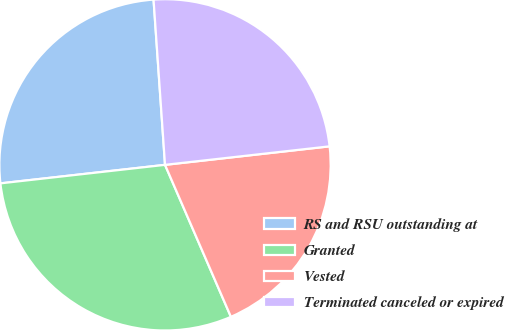Convert chart to OTSL. <chart><loc_0><loc_0><loc_500><loc_500><pie_chart><fcel>RS and RSU outstanding at<fcel>Granted<fcel>Vested<fcel>Terminated canceled or expired<nl><fcel>25.68%<fcel>29.73%<fcel>20.27%<fcel>24.32%<nl></chart> 